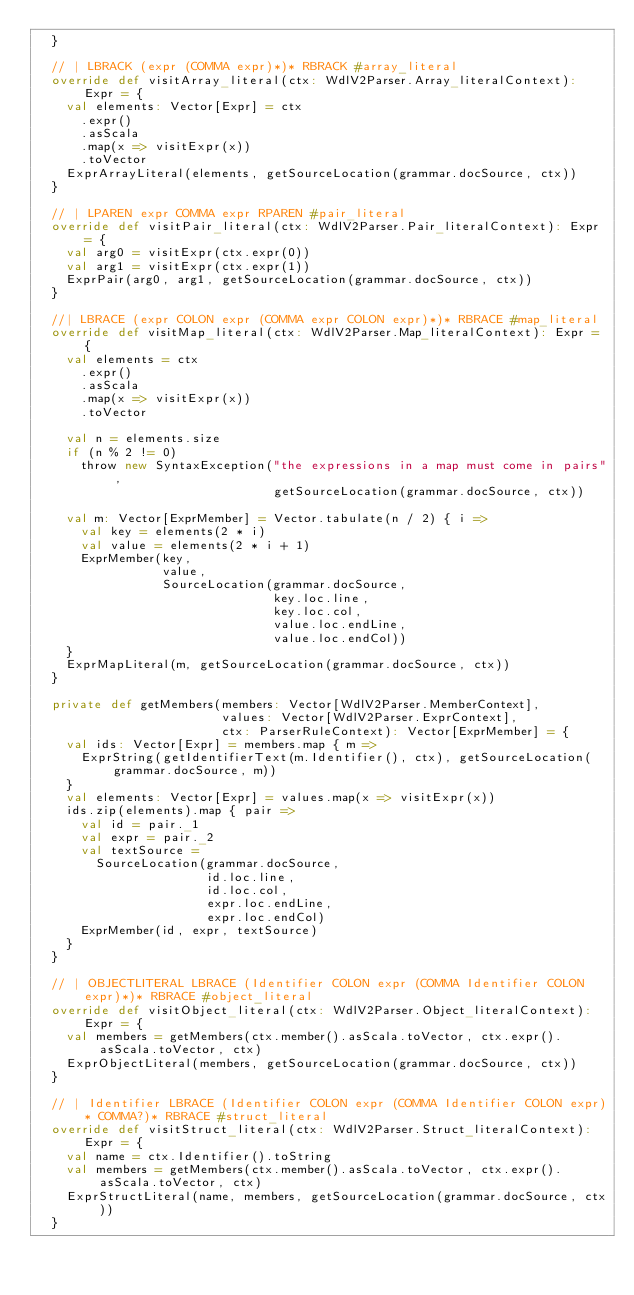Convert code to text. <code><loc_0><loc_0><loc_500><loc_500><_Scala_>  }

  // | LBRACK (expr (COMMA expr)*)* RBRACK #array_literal
  override def visitArray_literal(ctx: WdlV2Parser.Array_literalContext): Expr = {
    val elements: Vector[Expr] = ctx
      .expr()
      .asScala
      .map(x => visitExpr(x))
      .toVector
    ExprArrayLiteral(elements, getSourceLocation(grammar.docSource, ctx))
  }

  // | LPAREN expr COMMA expr RPAREN #pair_literal
  override def visitPair_literal(ctx: WdlV2Parser.Pair_literalContext): Expr = {
    val arg0 = visitExpr(ctx.expr(0))
    val arg1 = visitExpr(ctx.expr(1))
    ExprPair(arg0, arg1, getSourceLocation(grammar.docSource, ctx))
  }

  //| LBRACE (expr COLON expr (COMMA expr COLON expr)*)* RBRACE #map_literal
  override def visitMap_literal(ctx: WdlV2Parser.Map_literalContext): Expr = {
    val elements = ctx
      .expr()
      .asScala
      .map(x => visitExpr(x))
      .toVector

    val n = elements.size
    if (n % 2 != 0)
      throw new SyntaxException("the expressions in a map must come in pairs",
                                getSourceLocation(grammar.docSource, ctx))

    val m: Vector[ExprMember] = Vector.tabulate(n / 2) { i =>
      val key = elements(2 * i)
      val value = elements(2 * i + 1)
      ExprMember(key,
                 value,
                 SourceLocation(grammar.docSource,
                                key.loc.line,
                                key.loc.col,
                                value.loc.endLine,
                                value.loc.endCol))
    }
    ExprMapLiteral(m, getSourceLocation(grammar.docSource, ctx))
  }

  private def getMembers(members: Vector[WdlV2Parser.MemberContext],
                         values: Vector[WdlV2Parser.ExprContext],
                         ctx: ParserRuleContext): Vector[ExprMember] = {
    val ids: Vector[Expr] = members.map { m =>
      ExprString(getIdentifierText(m.Identifier(), ctx), getSourceLocation(grammar.docSource, m))
    }
    val elements: Vector[Expr] = values.map(x => visitExpr(x))
    ids.zip(elements).map { pair =>
      val id = pair._1
      val expr = pair._2
      val textSource =
        SourceLocation(grammar.docSource,
                       id.loc.line,
                       id.loc.col,
                       expr.loc.endLine,
                       expr.loc.endCol)
      ExprMember(id, expr, textSource)
    }
  }

  // | OBJECTLITERAL LBRACE (Identifier COLON expr (COMMA Identifier COLON expr)*)* RBRACE #object_literal
  override def visitObject_literal(ctx: WdlV2Parser.Object_literalContext): Expr = {
    val members = getMembers(ctx.member().asScala.toVector, ctx.expr().asScala.toVector, ctx)
    ExprObjectLiteral(members, getSourceLocation(grammar.docSource, ctx))
  }

  // | Identifier LBRACE (Identifier COLON expr (COMMA Identifier COLON expr)* COMMA?)* RBRACE #struct_literal
  override def visitStruct_literal(ctx: WdlV2Parser.Struct_literalContext): Expr = {
    val name = ctx.Identifier().toString
    val members = getMembers(ctx.member().asScala.toVector, ctx.expr().asScala.toVector, ctx)
    ExprStructLiteral(name, members, getSourceLocation(grammar.docSource, ctx))
  }
</code> 